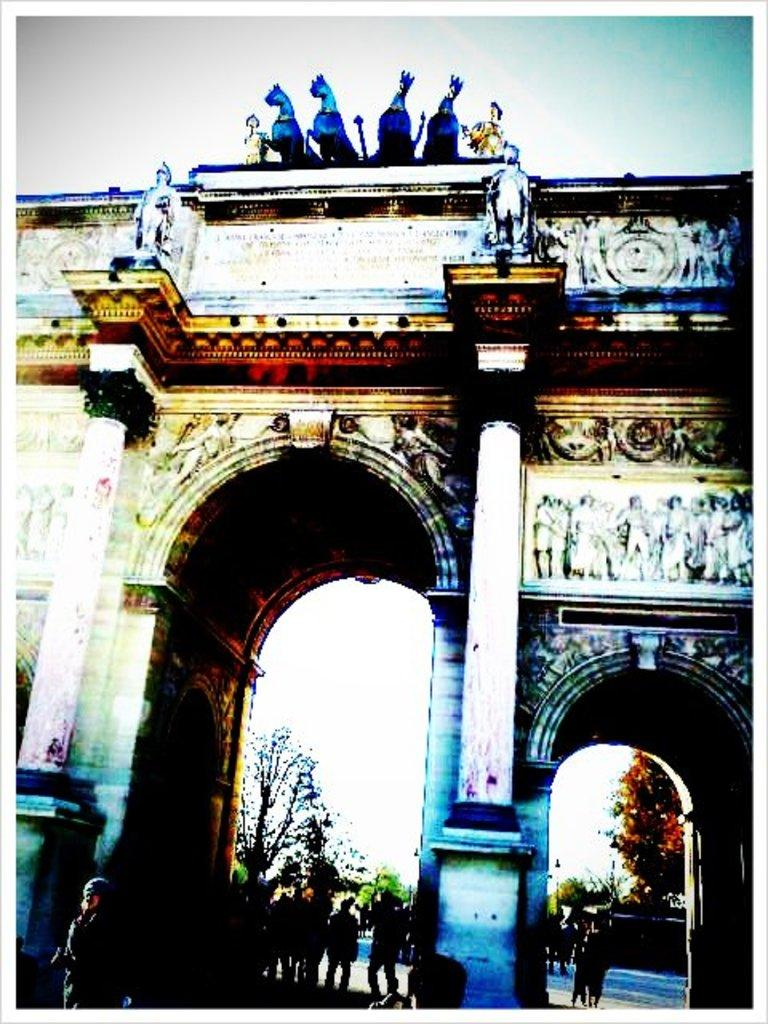What is the main structure visible in the image? There is a building in the image. Can you describe the people in the background of the image? There are people standing in the background of the image. What type of vegetation can be seen in the background of the image? There are trees with green color in the background of the image. What is the color of the sky in the image? The sky is visible in the image, and it appears to be white in color. How many lizards are sitting on the stone in the image? There are no lizards or stones present in the image. 